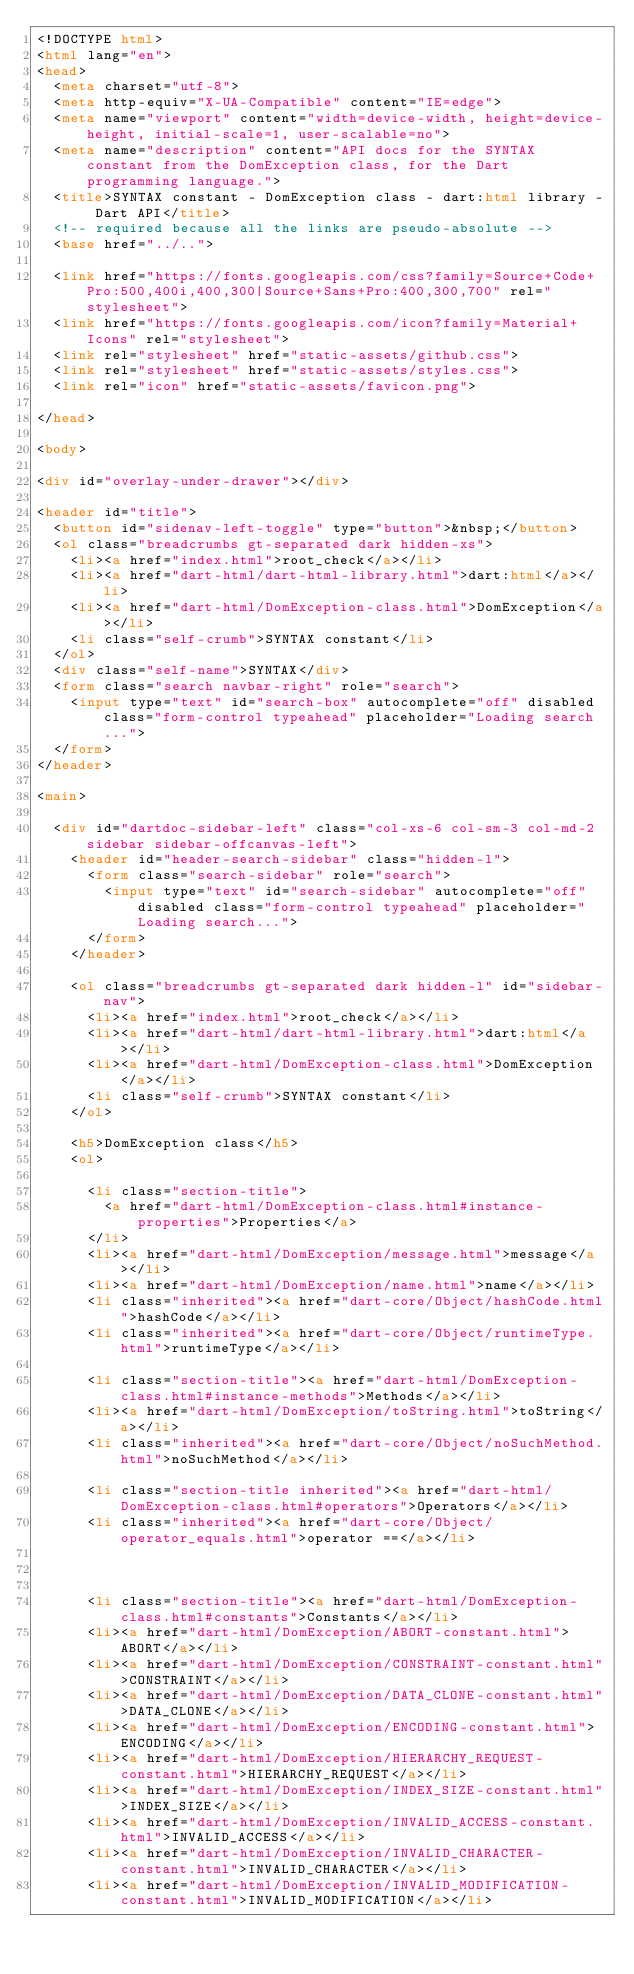<code> <loc_0><loc_0><loc_500><loc_500><_HTML_><!DOCTYPE html>
<html lang="en">
<head>
  <meta charset="utf-8">
  <meta http-equiv="X-UA-Compatible" content="IE=edge">
  <meta name="viewport" content="width=device-width, height=device-height, initial-scale=1, user-scalable=no">
  <meta name="description" content="API docs for the SYNTAX constant from the DomException class, for the Dart programming language.">
  <title>SYNTAX constant - DomException class - dart:html library - Dart API</title>
  <!-- required because all the links are pseudo-absolute -->
  <base href="../..">

  <link href="https://fonts.googleapis.com/css?family=Source+Code+Pro:500,400i,400,300|Source+Sans+Pro:400,300,700" rel="stylesheet">
  <link href="https://fonts.googleapis.com/icon?family=Material+Icons" rel="stylesheet">
  <link rel="stylesheet" href="static-assets/github.css">
  <link rel="stylesheet" href="static-assets/styles.css">
  <link rel="icon" href="static-assets/favicon.png">
  
</head>

<body>

<div id="overlay-under-drawer"></div>

<header id="title">
  <button id="sidenav-left-toggle" type="button">&nbsp;</button>
  <ol class="breadcrumbs gt-separated dark hidden-xs">
    <li><a href="index.html">root_check</a></li>
    <li><a href="dart-html/dart-html-library.html">dart:html</a></li>
    <li><a href="dart-html/DomException-class.html">DomException</a></li>
    <li class="self-crumb">SYNTAX constant</li>
  </ol>
  <div class="self-name">SYNTAX</div>
  <form class="search navbar-right" role="search">
    <input type="text" id="search-box" autocomplete="off" disabled class="form-control typeahead" placeholder="Loading search...">
  </form>
</header>

<main>

  <div id="dartdoc-sidebar-left" class="col-xs-6 col-sm-3 col-md-2 sidebar sidebar-offcanvas-left">
    <header id="header-search-sidebar" class="hidden-l">
      <form class="search-sidebar" role="search">
        <input type="text" id="search-sidebar" autocomplete="off" disabled class="form-control typeahead" placeholder="Loading search...">
      </form>
    </header>
    
    <ol class="breadcrumbs gt-separated dark hidden-l" id="sidebar-nav">
      <li><a href="index.html">root_check</a></li>
      <li><a href="dart-html/dart-html-library.html">dart:html</a></li>
      <li><a href="dart-html/DomException-class.html">DomException</a></li>
      <li class="self-crumb">SYNTAX constant</li>
    </ol>
    
    <h5>DomException class</h5>
    <ol>
    
      <li class="section-title">
        <a href="dart-html/DomException-class.html#instance-properties">Properties</a>
      </li>
      <li><a href="dart-html/DomException/message.html">message</a></li>
      <li><a href="dart-html/DomException/name.html">name</a></li>
      <li class="inherited"><a href="dart-core/Object/hashCode.html">hashCode</a></li>
      <li class="inherited"><a href="dart-core/Object/runtimeType.html">runtimeType</a></li>
    
      <li class="section-title"><a href="dart-html/DomException-class.html#instance-methods">Methods</a></li>
      <li><a href="dart-html/DomException/toString.html">toString</a></li>
      <li class="inherited"><a href="dart-core/Object/noSuchMethod.html">noSuchMethod</a></li>
    
      <li class="section-title inherited"><a href="dart-html/DomException-class.html#operators">Operators</a></li>
      <li class="inherited"><a href="dart-core/Object/operator_equals.html">operator ==</a></li>
    
    
    
      <li class="section-title"><a href="dart-html/DomException-class.html#constants">Constants</a></li>
      <li><a href="dart-html/DomException/ABORT-constant.html">ABORT</a></li>
      <li><a href="dart-html/DomException/CONSTRAINT-constant.html">CONSTRAINT</a></li>
      <li><a href="dart-html/DomException/DATA_CLONE-constant.html">DATA_CLONE</a></li>
      <li><a href="dart-html/DomException/ENCODING-constant.html">ENCODING</a></li>
      <li><a href="dart-html/DomException/HIERARCHY_REQUEST-constant.html">HIERARCHY_REQUEST</a></li>
      <li><a href="dart-html/DomException/INDEX_SIZE-constant.html">INDEX_SIZE</a></li>
      <li><a href="dart-html/DomException/INVALID_ACCESS-constant.html">INVALID_ACCESS</a></li>
      <li><a href="dart-html/DomException/INVALID_CHARACTER-constant.html">INVALID_CHARACTER</a></li>
      <li><a href="dart-html/DomException/INVALID_MODIFICATION-constant.html">INVALID_MODIFICATION</a></li></code> 